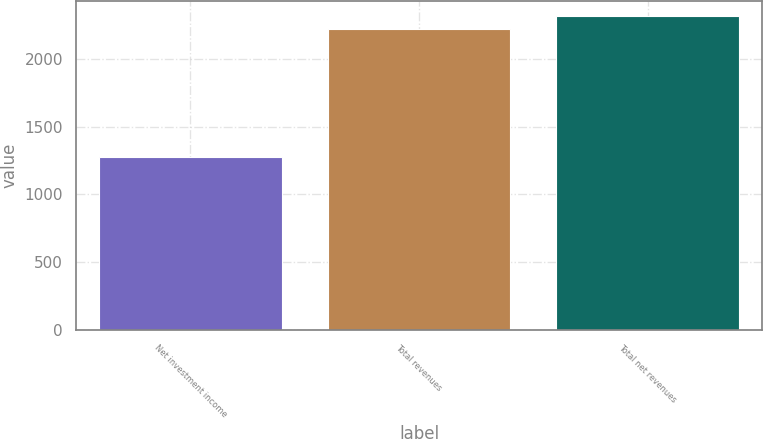Convert chart. <chart><loc_0><loc_0><loc_500><loc_500><bar_chart><fcel>Net investment income<fcel>Total revenues<fcel>Total net revenues<nl><fcel>1279<fcel>2221<fcel>2315.2<nl></chart> 